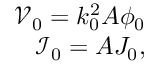<formula> <loc_0><loc_0><loc_500><loc_500>\begin{array} { r } { \mathcal { V } _ { 0 } = k _ { 0 } ^ { 2 } A \phi _ { 0 } } \\ { \mathcal { I } _ { 0 } = A J _ { 0 } , } \end{array}</formula> 